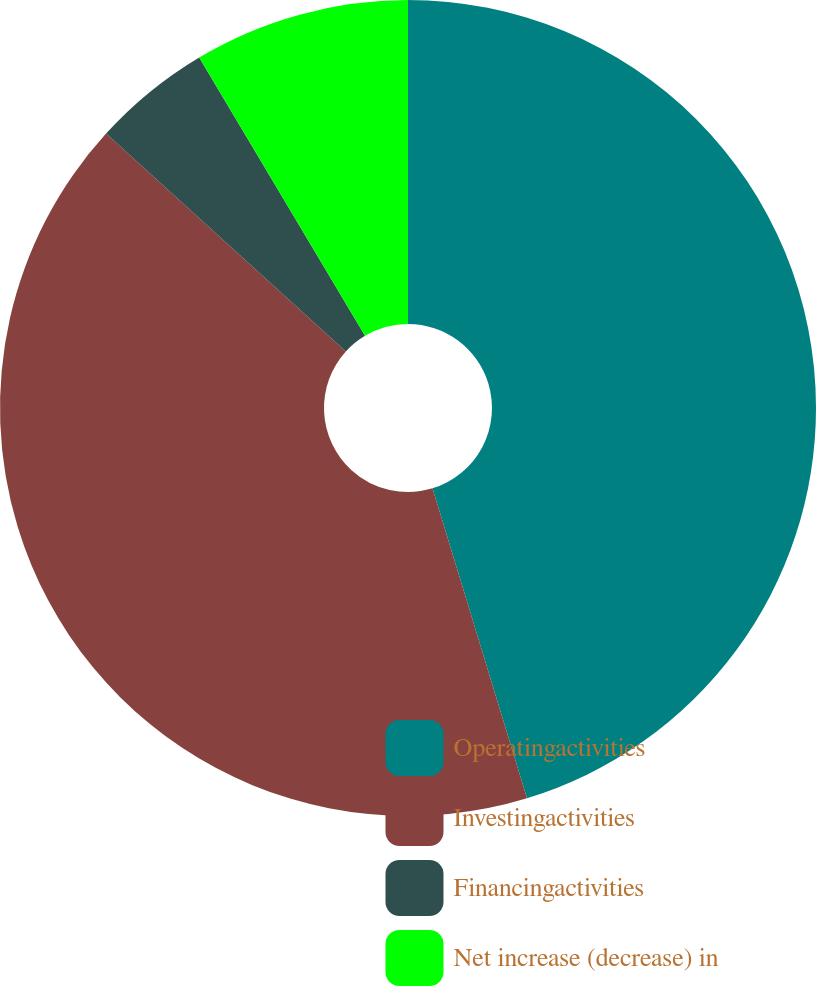<chart> <loc_0><loc_0><loc_500><loc_500><pie_chart><fcel>Operatingactivities<fcel>Investingactivities<fcel>Financingactivities<fcel>Net increase (decrease) in<nl><fcel>45.29%<fcel>41.45%<fcel>4.71%<fcel>8.55%<nl></chart> 